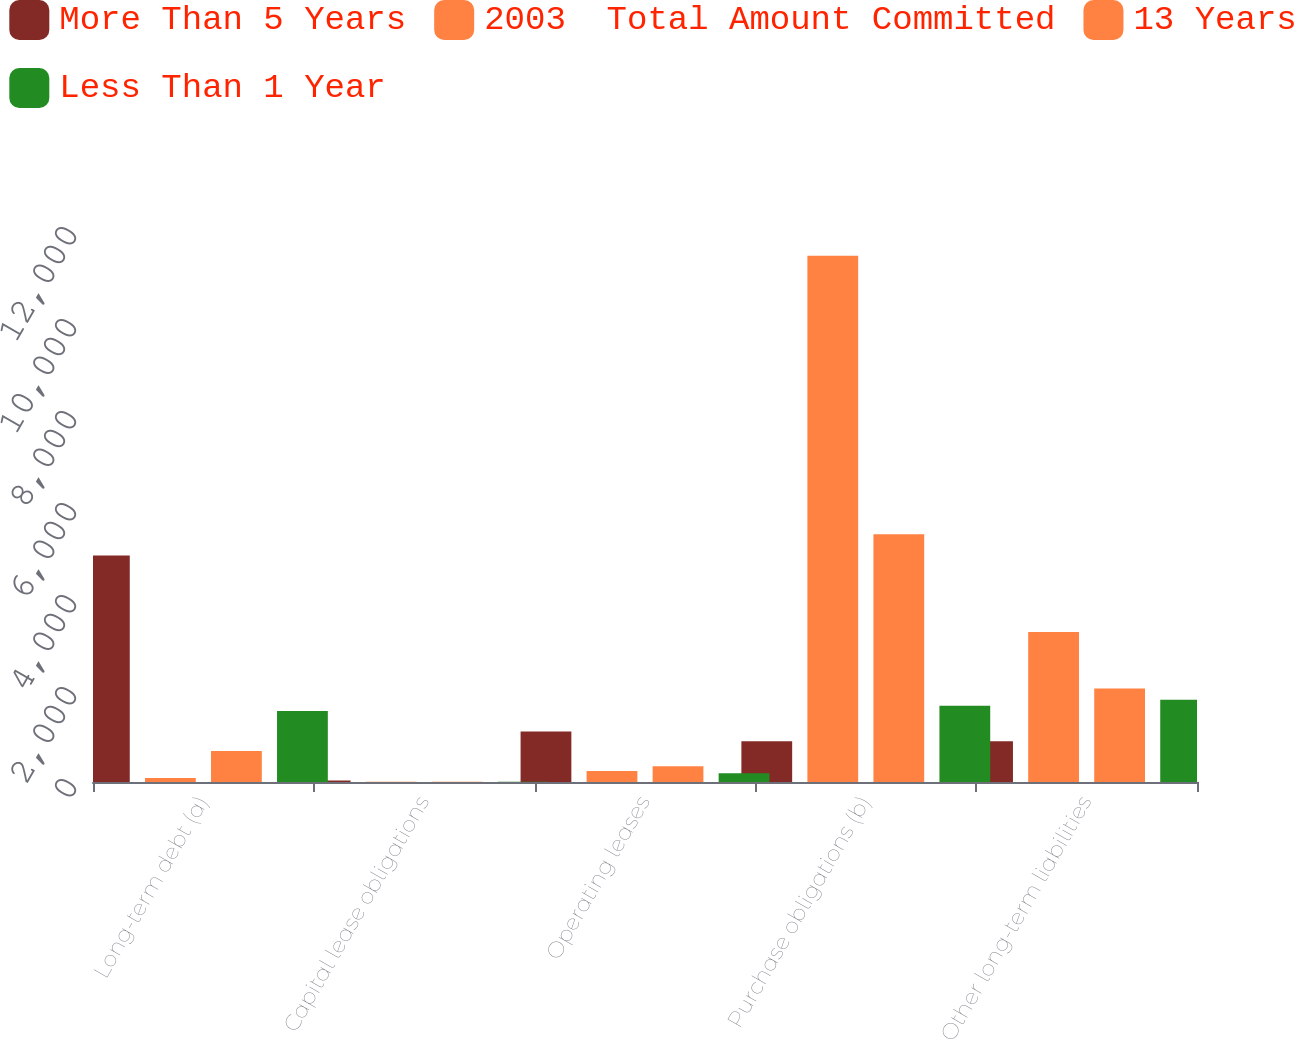<chart> <loc_0><loc_0><loc_500><loc_500><stacked_bar_chart><ecel><fcel>Long-term debt (a)<fcel>Capital lease obligations<fcel>Operating leases<fcel>Purchase obligations (b)<fcel>Other long-term liabilities<nl><fcel>More Than 5 Years<fcel>4923<fcel>34<fcel>1099<fcel>886<fcel>886<nl><fcel>2003  Total Amount Committed<fcel>89<fcel>3<fcel>239<fcel>11440<fcel>3259<nl><fcel>13 Years<fcel>673<fcel>4<fcel>341<fcel>5385<fcel>2035<nl><fcel>Less Than 1 Year<fcel>1546<fcel>4<fcel>188<fcel>1659<fcel>1790<nl></chart> 